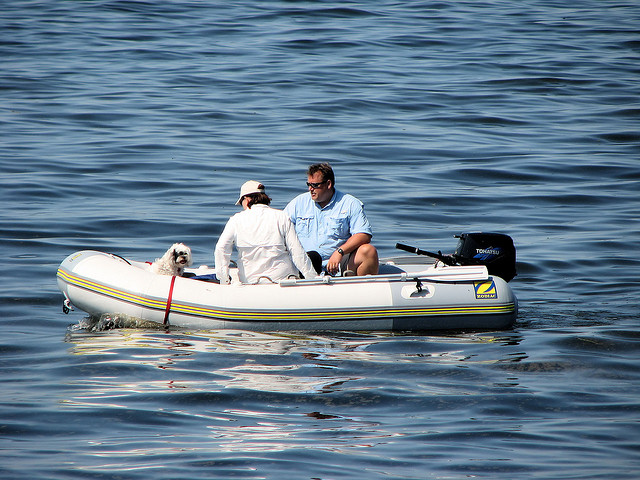<image>Is the dog having fun? It's ambiguous to determine if the dog is having fun. Is the dog having fun? I don't know if the dog is having fun. It can be both yes and no. 